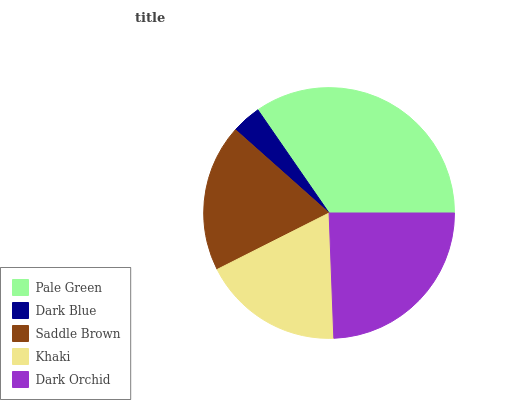Is Dark Blue the minimum?
Answer yes or no. Yes. Is Pale Green the maximum?
Answer yes or no. Yes. Is Saddle Brown the minimum?
Answer yes or no. No. Is Saddle Brown the maximum?
Answer yes or no. No. Is Saddle Brown greater than Dark Blue?
Answer yes or no. Yes. Is Dark Blue less than Saddle Brown?
Answer yes or no. Yes. Is Dark Blue greater than Saddle Brown?
Answer yes or no. No. Is Saddle Brown less than Dark Blue?
Answer yes or no. No. Is Saddle Brown the high median?
Answer yes or no. Yes. Is Saddle Brown the low median?
Answer yes or no. Yes. Is Khaki the high median?
Answer yes or no. No. Is Pale Green the low median?
Answer yes or no. No. 